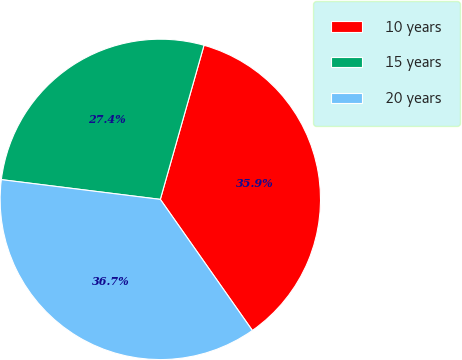<chart> <loc_0><loc_0><loc_500><loc_500><pie_chart><fcel>10 years<fcel>15 years<fcel>20 years<nl><fcel>35.86%<fcel>27.43%<fcel>36.71%<nl></chart> 